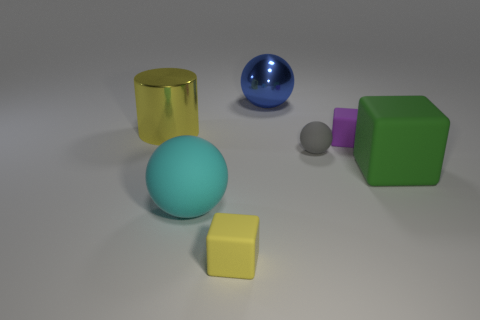Subtract all purple matte cubes. How many cubes are left? 2 Add 2 green cylinders. How many objects exist? 9 Subtract all purple cubes. How many cubes are left? 2 Subtract all cubes. How many objects are left? 4 Subtract 2 balls. How many balls are left? 1 Subtract all brown blocks. Subtract all blue cylinders. How many blocks are left? 3 Subtract all green cylinders. How many yellow balls are left? 0 Subtract all tiny blue balls. Subtract all green matte objects. How many objects are left? 6 Add 2 blue metallic objects. How many blue metallic objects are left? 3 Add 4 small yellow things. How many small yellow things exist? 5 